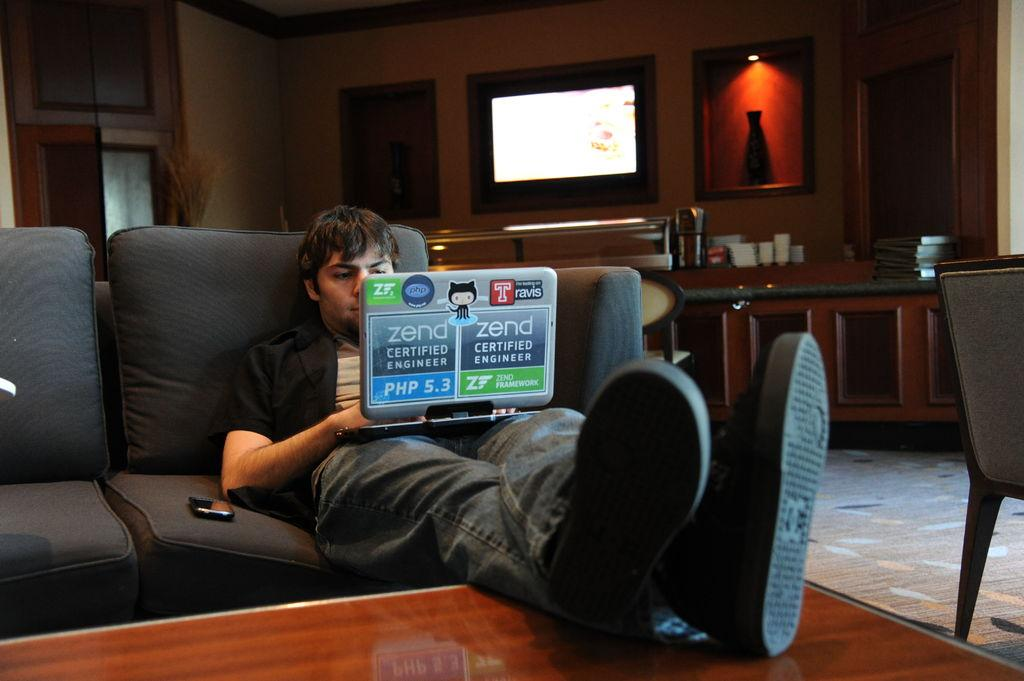What is the person doing in the image? The person is sitting on a couch and working on a laptop. What device is beside the person? There is a mobile beside the person. What electronic device can be seen in the image? There is a television in the image. What decorative item is on the wall? There is a vase on the wall. What items are on the table? There are files and other things on the table. Is the person feeling angry while working on the laptop in the image? There is no indication of the person's emotions in the image, so it cannot be determined if they are feeling angry or not. 